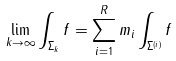Convert formula to latex. <formula><loc_0><loc_0><loc_500><loc_500>\lim _ { k \rightarrow \infty } \int _ { \Sigma _ { k } } f = \sum _ { i = 1 } ^ { R } m _ { i } \int _ { \Sigma ^ { ( i ) } } f</formula> 